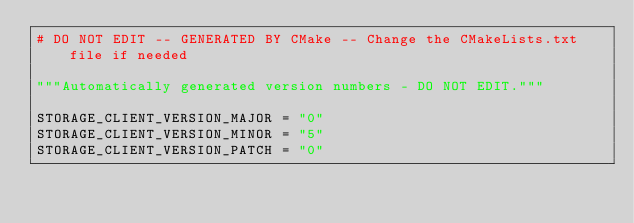Convert code to text. <code><loc_0><loc_0><loc_500><loc_500><_Python_># DO NOT EDIT -- GENERATED BY CMake -- Change the CMakeLists.txt file if needed

"""Automatically generated version numbers - DO NOT EDIT."""

STORAGE_CLIENT_VERSION_MAJOR = "0"
STORAGE_CLIENT_VERSION_MINOR = "5"
STORAGE_CLIENT_VERSION_PATCH = "0"
</code> 